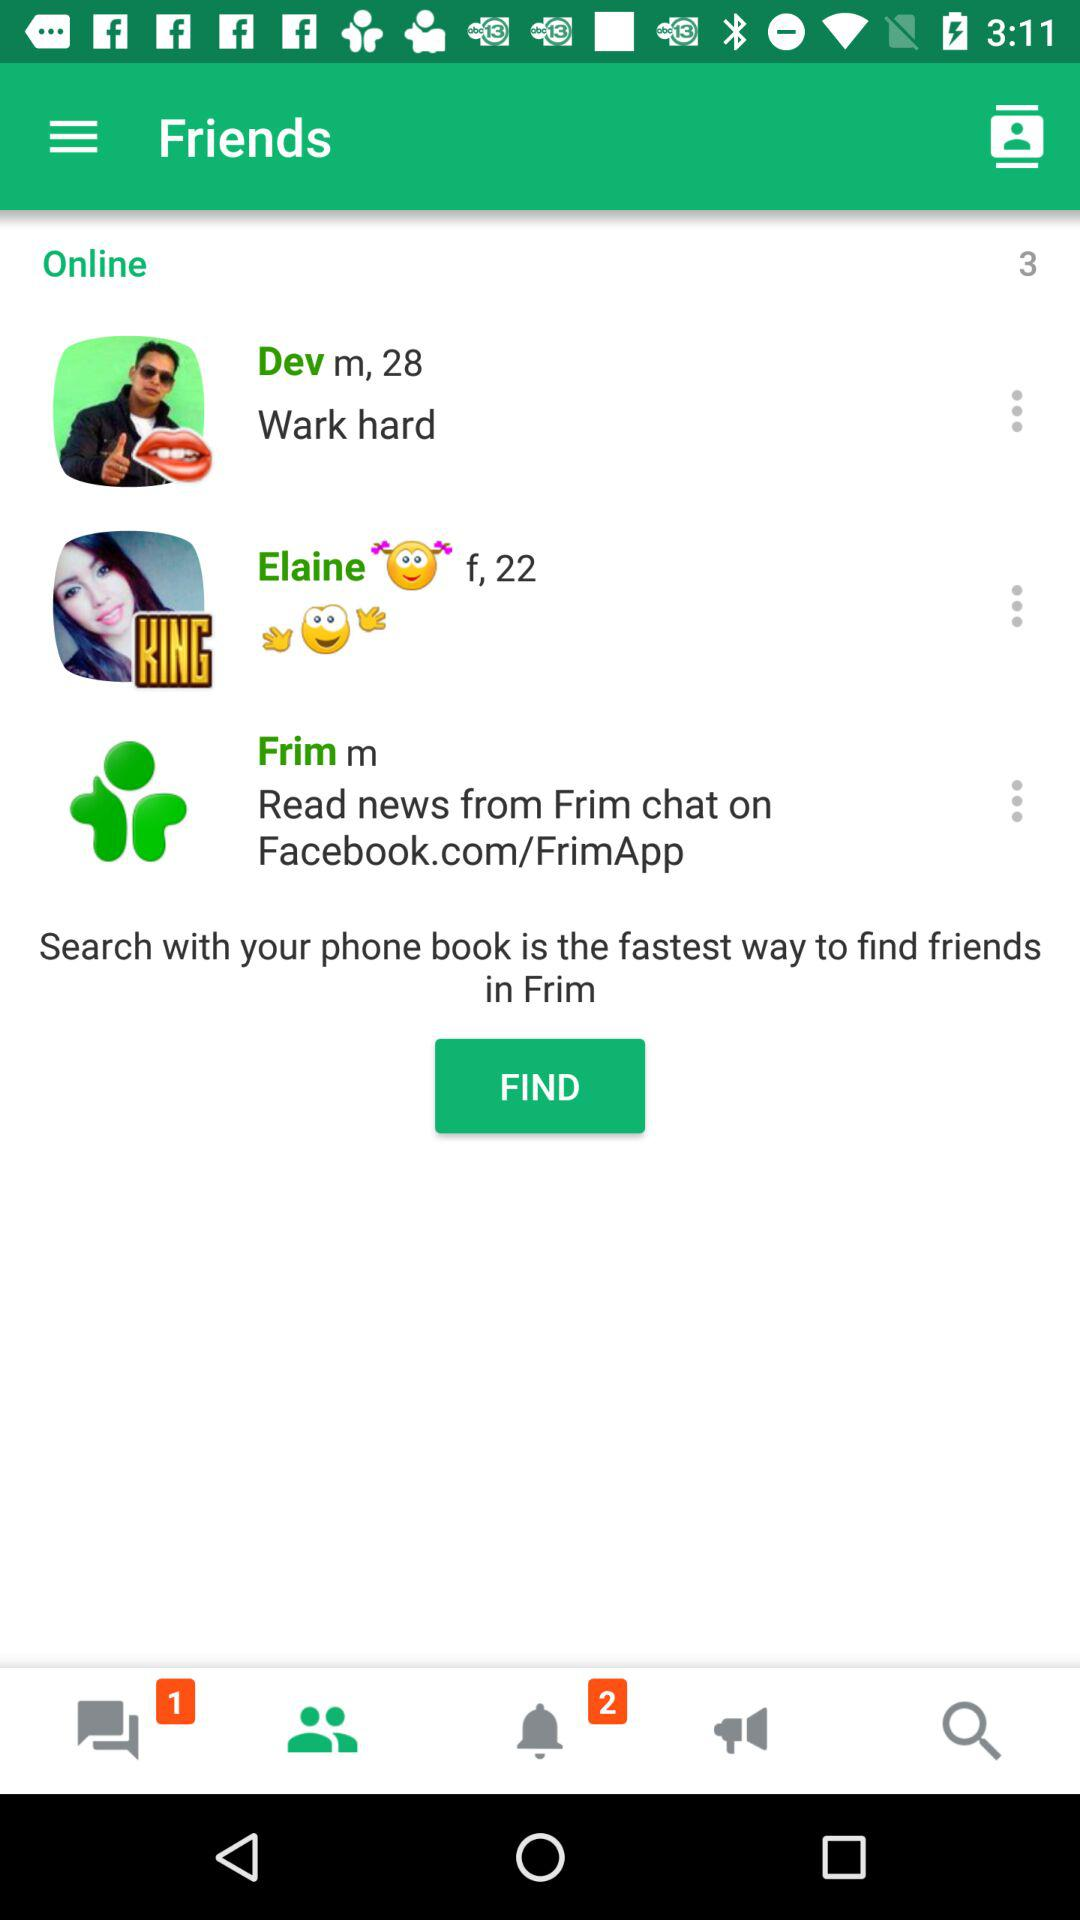What is the fastest way to find friends in "Frim"? The fastest way to find friends in "Frim" is to search with your phone book. 